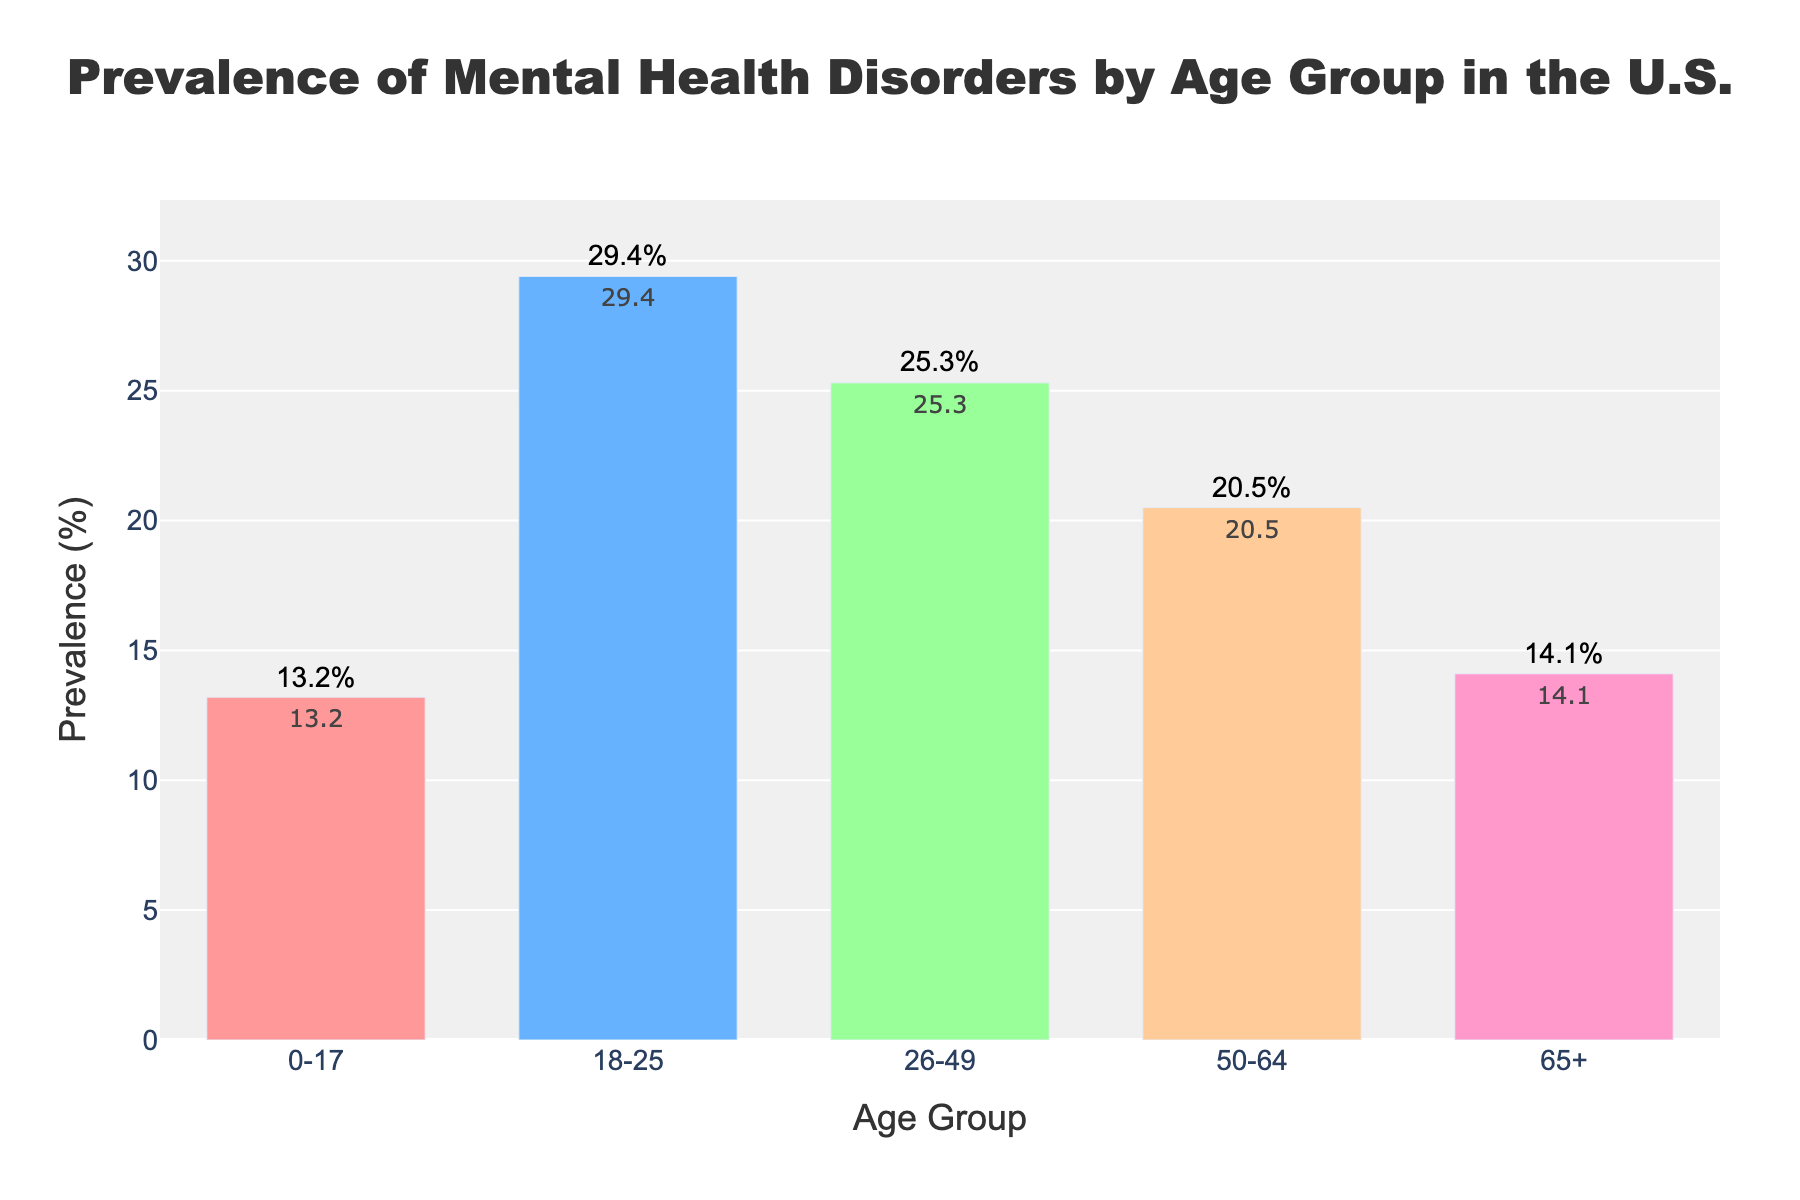What is the prevalence of mental health disorders in the age group 18-25? The bar for the 18-25 age group is labeled with a prevalence of 29.4%.
Answer: 29.4% Which age group has the lowest prevalence of mental health disorders? By comparing the heights of all bars, the 0-17 age group has the shortest bar with a prevalence of 13.2%.
Answer: 0-17 How does the prevalence of mental health disorders in the 50-64 age group compare to the 65+ age group? The bar for the 50-64 age group shows a prevalence of 20.5%, while the bar for the 65+ age group shows a prevalence of 14.1%. Therefore, the prevalence in the 50-64 age group is higher.
Answer: 50-64 is higher What is the average prevalence of mental health disorders across all age groups? Add the prevalences of all age groups: 13.2 + 29.4 + 25.3 + 20.5 + 14.1 = 102.5, then divide by 5 age groups. Average = 102.5 / 5 = 20.5%.
Answer: 20.5% What is the difference in prevalence between the age groups 26-49 and 0-17? The prevalence for the 26-49 age group is 25.3% and for the 0-17 age group is 13.2%. The difference is 25.3 - 13.2 = 12.1%.
Answer: 12.1% Which bar represents the age group with the highest prevalence of mental health disorders? The bar for the 18-25 age group is the tallest, indicating the highest prevalence at 29.4%.
Answer: 18-25 What is the combined prevalence of mental health disorders for the age groups 0-17 and 65+? Add the prevalences of the 0-17 and 65+ age groups: 13.2 + 14.1 = 27.3%.
Answer: 27.3% By how much does the prevalence of the age group 26-49 exceed that of the 65+ group? The bar for the 26-49 age group shows a prevalence of 25.3%, and the bar for the 65+ group shows a prevalence of 14.1%. The difference is 25.3 - 14.1 = 11.2%.
Answer: 11.2% What is the median prevalence of mental health disorders among the listed age groups? Arrange the prevalence percentages in ascending order: 13.2, 14.1, 20.5, 25.3, 29.4. The median value is the middle one, which is 20.5%.
Answer: 20.5% If you combined the age groups 18-25 and 26-49, what would be the total prevalence? Add the prevalences of the 18-25 and 26-49 age groups: 29.4 + 25.3 = 54.7%.
Answer: 54.7% 